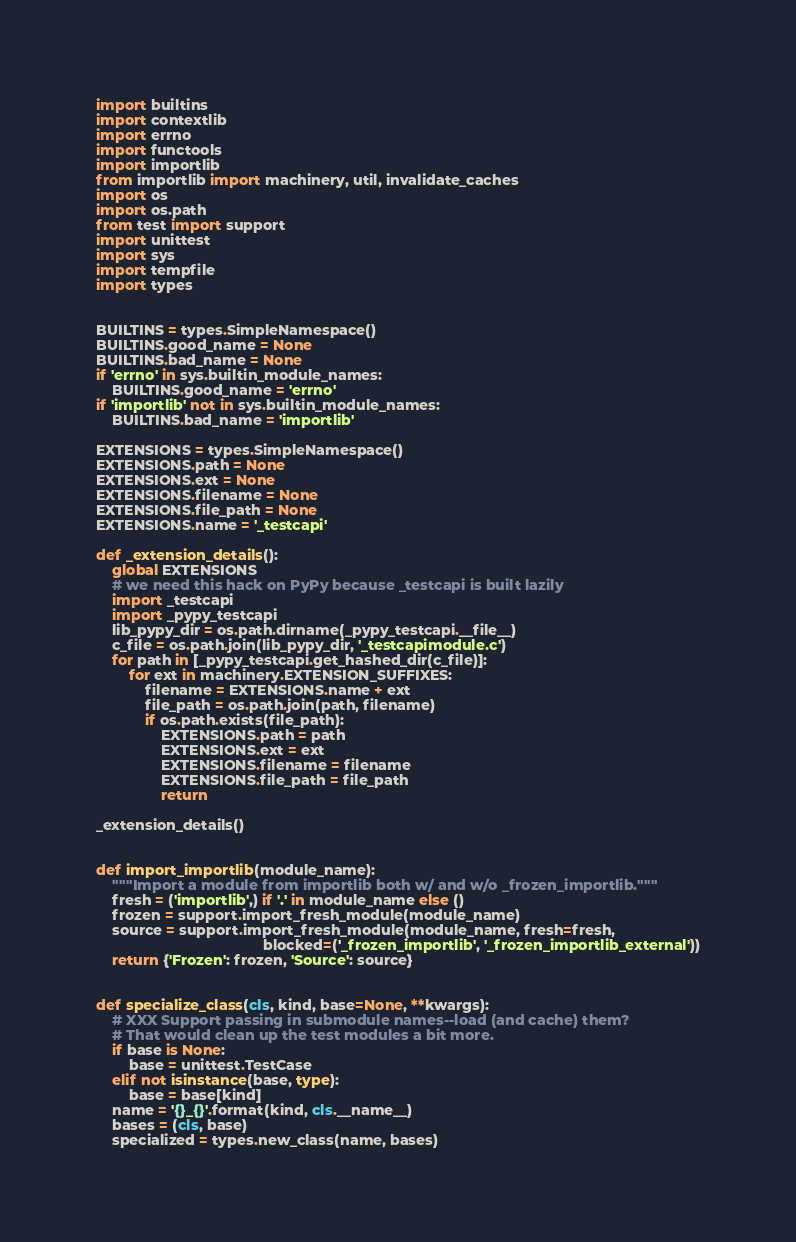Convert code to text. <code><loc_0><loc_0><loc_500><loc_500><_Python_>import builtins
import contextlib
import errno
import functools
import importlib
from importlib import machinery, util, invalidate_caches
import os
import os.path
from test import support
import unittest
import sys
import tempfile
import types


BUILTINS = types.SimpleNamespace()
BUILTINS.good_name = None
BUILTINS.bad_name = None
if 'errno' in sys.builtin_module_names:
    BUILTINS.good_name = 'errno'
if 'importlib' not in sys.builtin_module_names:
    BUILTINS.bad_name = 'importlib'

EXTENSIONS = types.SimpleNamespace()
EXTENSIONS.path = None
EXTENSIONS.ext = None
EXTENSIONS.filename = None
EXTENSIONS.file_path = None
EXTENSIONS.name = '_testcapi'

def _extension_details():
    global EXTENSIONS
    # we need this hack on PyPy because _testcapi is built lazily
    import _testcapi
    import _pypy_testcapi
    lib_pypy_dir = os.path.dirname(_pypy_testcapi.__file__)
    c_file = os.path.join(lib_pypy_dir, '_testcapimodule.c')
    for path in [_pypy_testcapi.get_hashed_dir(c_file)]:
        for ext in machinery.EXTENSION_SUFFIXES:
            filename = EXTENSIONS.name + ext
            file_path = os.path.join(path, filename)
            if os.path.exists(file_path):
                EXTENSIONS.path = path
                EXTENSIONS.ext = ext
                EXTENSIONS.filename = filename
                EXTENSIONS.file_path = file_path
                return

_extension_details()


def import_importlib(module_name):
    """Import a module from importlib both w/ and w/o _frozen_importlib."""
    fresh = ('importlib',) if '.' in module_name else ()
    frozen = support.import_fresh_module(module_name)
    source = support.import_fresh_module(module_name, fresh=fresh,
                                         blocked=('_frozen_importlib', '_frozen_importlib_external'))
    return {'Frozen': frozen, 'Source': source}


def specialize_class(cls, kind, base=None, **kwargs):
    # XXX Support passing in submodule names--load (and cache) them?
    # That would clean up the test modules a bit more.
    if base is None:
        base = unittest.TestCase
    elif not isinstance(base, type):
        base = base[kind]
    name = '{}_{}'.format(kind, cls.__name__)
    bases = (cls, base)
    specialized = types.new_class(name, bases)</code> 